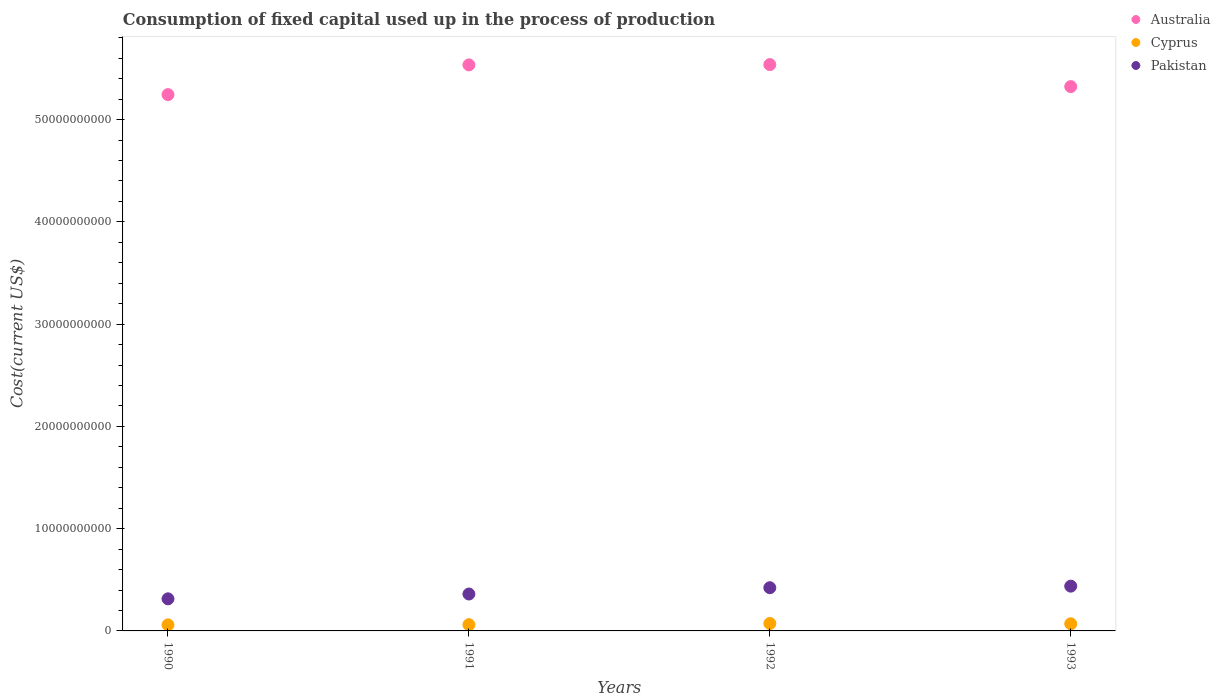What is the amount consumed in the process of production in Cyprus in 1993?
Ensure brevity in your answer.  6.96e+08. Across all years, what is the maximum amount consumed in the process of production in Pakistan?
Provide a short and direct response. 4.38e+09. Across all years, what is the minimum amount consumed in the process of production in Pakistan?
Provide a short and direct response. 3.14e+09. In which year was the amount consumed in the process of production in Pakistan maximum?
Give a very brief answer. 1993. What is the total amount consumed in the process of production in Australia in the graph?
Your answer should be very brief. 2.16e+11. What is the difference between the amount consumed in the process of production in Cyprus in 1991 and that in 1993?
Offer a very short reply. -8.46e+07. What is the difference between the amount consumed in the process of production in Australia in 1993 and the amount consumed in the process of production in Cyprus in 1990?
Your answer should be compact. 5.26e+1. What is the average amount consumed in the process of production in Australia per year?
Offer a very short reply. 5.41e+1. In the year 1992, what is the difference between the amount consumed in the process of production in Australia and amount consumed in the process of production in Cyprus?
Provide a short and direct response. 5.47e+1. In how many years, is the amount consumed in the process of production in Australia greater than 2000000000 US$?
Give a very brief answer. 4. What is the ratio of the amount consumed in the process of production in Australia in 1990 to that in 1992?
Give a very brief answer. 0.95. Is the amount consumed in the process of production in Pakistan in 1991 less than that in 1992?
Provide a succinct answer. Yes. What is the difference between the highest and the second highest amount consumed in the process of production in Cyprus?
Offer a very short reply. 3.25e+07. What is the difference between the highest and the lowest amount consumed in the process of production in Cyprus?
Make the answer very short. 1.37e+08. In how many years, is the amount consumed in the process of production in Cyprus greater than the average amount consumed in the process of production in Cyprus taken over all years?
Ensure brevity in your answer.  2. Does the amount consumed in the process of production in Cyprus monotonically increase over the years?
Your response must be concise. No. Is the amount consumed in the process of production in Cyprus strictly greater than the amount consumed in the process of production in Australia over the years?
Make the answer very short. No. How many years are there in the graph?
Make the answer very short. 4. Does the graph contain any zero values?
Provide a succinct answer. No. Does the graph contain grids?
Make the answer very short. No. How are the legend labels stacked?
Your response must be concise. Vertical. What is the title of the graph?
Provide a succinct answer. Consumption of fixed capital used up in the process of production. Does "Yemen, Rep." appear as one of the legend labels in the graph?
Give a very brief answer. No. What is the label or title of the Y-axis?
Offer a very short reply. Cost(current US$). What is the Cost(current US$) in Australia in 1990?
Ensure brevity in your answer.  5.24e+1. What is the Cost(current US$) in Cyprus in 1990?
Keep it short and to the point. 5.92e+08. What is the Cost(current US$) of Pakistan in 1990?
Offer a very short reply. 3.14e+09. What is the Cost(current US$) in Australia in 1991?
Offer a very short reply. 5.54e+1. What is the Cost(current US$) in Cyprus in 1991?
Ensure brevity in your answer.  6.12e+08. What is the Cost(current US$) of Pakistan in 1991?
Ensure brevity in your answer.  3.61e+09. What is the Cost(current US$) of Australia in 1992?
Offer a very short reply. 5.54e+1. What is the Cost(current US$) in Cyprus in 1992?
Offer a very short reply. 7.29e+08. What is the Cost(current US$) of Pakistan in 1992?
Keep it short and to the point. 4.23e+09. What is the Cost(current US$) of Australia in 1993?
Give a very brief answer. 5.32e+1. What is the Cost(current US$) of Cyprus in 1993?
Provide a succinct answer. 6.96e+08. What is the Cost(current US$) of Pakistan in 1993?
Your answer should be very brief. 4.38e+09. Across all years, what is the maximum Cost(current US$) in Australia?
Offer a terse response. 5.54e+1. Across all years, what is the maximum Cost(current US$) of Cyprus?
Offer a very short reply. 7.29e+08. Across all years, what is the maximum Cost(current US$) in Pakistan?
Make the answer very short. 4.38e+09. Across all years, what is the minimum Cost(current US$) of Australia?
Offer a terse response. 5.24e+1. Across all years, what is the minimum Cost(current US$) in Cyprus?
Provide a short and direct response. 5.92e+08. Across all years, what is the minimum Cost(current US$) of Pakistan?
Keep it short and to the point. 3.14e+09. What is the total Cost(current US$) of Australia in the graph?
Provide a short and direct response. 2.16e+11. What is the total Cost(current US$) in Cyprus in the graph?
Your answer should be very brief. 2.63e+09. What is the total Cost(current US$) of Pakistan in the graph?
Offer a terse response. 1.54e+1. What is the difference between the Cost(current US$) in Australia in 1990 and that in 1991?
Your answer should be very brief. -2.91e+09. What is the difference between the Cost(current US$) in Cyprus in 1990 and that in 1991?
Your response must be concise. -1.96e+07. What is the difference between the Cost(current US$) of Pakistan in 1990 and that in 1991?
Provide a short and direct response. -4.72e+08. What is the difference between the Cost(current US$) of Australia in 1990 and that in 1992?
Offer a very short reply. -2.94e+09. What is the difference between the Cost(current US$) of Cyprus in 1990 and that in 1992?
Offer a very short reply. -1.37e+08. What is the difference between the Cost(current US$) of Pakistan in 1990 and that in 1992?
Your answer should be compact. -1.09e+09. What is the difference between the Cost(current US$) of Australia in 1990 and that in 1993?
Offer a terse response. -7.84e+08. What is the difference between the Cost(current US$) of Cyprus in 1990 and that in 1993?
Provide a short and direct response. -1.04e+08. What is the difference between the Cost(current US$) in Pakistan in 1990 and that in 1993?
Give a very brief answer. -1.24e+09. What is the difference between the Cost(current US$) in Australia in 1991 and that in 1992?
Give a very brief answer. -2.84e+07. What is the difference between the Cost(current US$) in Cyprus in 1991 and that in 1992?
Your answer should be compact. -1.17e+08. What is the difference between the Cost(current US$) in Pakistan in 1991 and that in 1992?
Offer a terse response. -6.16e+08. What is the difference between the Cost(current US$) of Australia in 1991 and that in 1993?
Provide a short and direct response. 2.12e+09. What is the difference between the Cost(current US$) in Cyprus in 1991 and that in 1993?
Your response must be concise. -8.46e+07. What is the difference between the Cost(current US$) in Pakistan in 1991 and that in 1993?
Keep it short and to the point. -7.68e+08. What is the difference between the Cost(current US$) in Australia in 1992 and that in 1993?
Make the answer very short. 2.15e+09. What is the difference between the Cost(current US$) in Cyprus in 1992 and that in 1993?
Offer a terse response. 3.25e+07. What is the difference between the Cost(current US$) in Pakistan in 1992 and that in 1993?
Offer a terse response. -1.52e+08. What is the difference between the Cost(current US$) of Australia in 1990 and the Cost(current US$) of Cyprus in 1991?
Offer a very short reply. 5.18e+1. What is the difference between the Cost(current US$) of Australia in 1990 and the Cost(current US$) of Pakistan in 1991?
Provide a succinct answer. 4.88e+1. What is the difference between the Cost(current US$) of Cyprus in 1990 and the Cost(current US$) of Pakistan in 1991?
Your answer should be very brief. -3.02e+09. What is the difference between the Cost(current US$) in Australia in 1990 and the Cost(current US$) in Cyprus in 1992?
Your response must be concise. 5.17e+1. What is the difference between the Cost(current US$) of Australia in 1990 and the Cost(current US$) of Pakistan in 1992?
Make the answer very short. 4.82e+1. What is the difference between the Cost(current US$) of Cyprus in 1990 and the Cost(current US$) of Pakistan in 1992?
Offer a terse response. -3.63e+09. What is the difference between the Cost(current US$) in Australia in 1990 and the Cost(current US$) in Cyprus in 1993?
Offer a very short reply. 5.17e+1. What is the difference between the Cost(current US$) of Australia in 1990 and the Cost(current US$) of Pakistan in 1993?
Your answer should be very brief. 4.81e+1. What is the difference between the Cost(current US$) in Cyprus in 1990 and the Cost(current US$) in Pakistan in 1993?
Keep it short and to the point. -3.79e+09. What is the difference between the Cost(current US$) of Australia in 1991 and the Cost(current US$) of Cyprus in 1992?
Keep it short and to the point. 5.46e+1. What is the difference between the Cost(current US$) in Australia in 1991 and the Cost(current US$) in Pakistan in 1992?
Your answer should be very brief. 5.11e+1. What is the difference between the Cost(current US$) of Cyprus in 1991 and the Cost(current US$) of Pakistan in 1992?
Offer a very short reply. -3.61e+09. What is the difference between the Cost(current US$) in Australia in 1991 and the Cost(current US$) in Cyprus in 1993?
Give a very brief answer. 5.47e+1. What is the difference between the Cost(current US$) of Australia in 1991 and the Cost(current US$) of Pakistan in 1993?
Offer a terse response. 5.10e+1. What is the difference between the Cost(current US$) of Cyprus in 1991 and the Cost(current US$) of Pakistan in 1993?
Make the answer very short. -3.77e+09. What is the difference between the Cost(current US$) of Australia in 1992 and the Cost(current US$) of Cyprus in 1993?
Offer a terse response. 5.47e+1. What is the difference between the Cost(current US$) in Australia in 1992 and the Cost(current US$) in Pakistan in 1993?
Your answer should be compact. 5.10e+1. What is the difference between the Cost(current US$) in Cyprus in 1992 and the Cost(current US$) in Pakistan in 1993?
Ensure brevity in your answer.  -3.65e+09. What is the average Cost(current US$) in Australia per year?
Make the answer very short. 5.41e+1. What is the average Cost(current US$) of Cyprus per year?
Give a very brief answer. 6.57e+08. What is the average Cost(current US$) in Pakistan per year?
Give a very brief answer. 3.84e+09. In the year 1990, what is the difference between the Cost(current US$) of Australia and Cost(current US$) of Cyprus?
Give a very brief answer. 5.19e+1. In the year 1990, what is the difference between the Cost(current US$) of Australia and Cost(current US$) of Pakistan?
Your answer should be very brief. 4.93e+1. In the year 1990, what is the difference between the Cost(current US$) of Cyprus and Cost(current US$) of Pakistan?
Offer a very short reply. -2.55e+09. In the year 1991, what is the difference between the Cost(current US$) in Australia and Cost(current US$) in Cyprus?
Your answer should be compact. 5.47e+1. In the year 1991, what is the difference between the Cost(current US$) of Australia and Cost(current US$) of Pakistan?
Make the answer very short. 5.17e+1. In the year 1991, what is the difference between the Cost(current US$) in Cyprus and Cost(current US$) in Pakistan?
Provide a short and direct response. -3.00e+09. In the year 1992, what is the difference between the Cost(current US$) of Australia and Cost(current US$) of Cyprus?
Keep it short and to the point. 5.47e+1. In the year 1992, what is the difference between the Cost(current US$) in Australia and Cost(current US$) in Pakistan?
Give a very brief answer. 5.12e+1. In the year 1992, what is the difference between the Cost(current US$) in Cyprus and Cost(current US$) in Pakistan?
Ensure brevity in your answer.  -3.50e+09. In the year 1993, what is the difference between the Cost(current US$) of Australia and Cost(current US$) of Cyprus?
Your response must be concise. 5.25e+1. In the year 1993, what is the difference between the Cost(current US$) of Australia and Cost(current US$) of Pakistan?
Ensure brevity in your answer.  4.89e+1. In the year 1993, what is the difference between the Cost(current US$) of Cyprus and Cost(current US$) of Pakistan?
Provide a short and direct response. -3.68e+09. What is the ratio of the Cost(current US$) in Australia in 1990 to that in 1991?
Your answer should be compact. 0.95. What is the ratio of the Cost(current US$) in Cyprus in 1990 to that in 1991?
Give a very brief answer. 0.97. What is the ratio of the Cost(current US$) of Pakistan in 1990 to that in 1991?
Your answer should be very brief. 0.87. What is the ratio of the Cost(current US$) in Australia in 1990 to that in 1992?
Give a very brief answer. 0.95. What is the ratio of the Cost(current US$) in Cyprus in 1990 to that in 1992?
Your answer should be compact. 0.81. What is the ratio of the Cost(current US$) of Pakistan in 1990 to that in 1992?
Provide a short and direct response. 0.74. What is the ratio of the Cost(current US$) of Australia in 1990 to that in 1993?
Your answer should be compact. 0.99. What is the ratio of the Cost(current US$) of Cyprus in 1990 to that in 1993?
Provide a short and direct response. 0.85. What is the ratio of the Cost(current US$) of Pakistan in 1990 to that in 1993?
Make the answer very short. 0.72. What is the ratio of the Cost(current US$) in Cyprus in 1991 to that in 1992?
Your answer should be compact. 0.84. What is the ratio of the Cost(current US$) in Pakistan in 1991 to that in 1992?
Provide a succinct answer. 0.85. What is the ratio of the Cost(current US$) of Australia in 1991 to that in 1993?
Keep it short and to the point. 1.04. What is the ratio of the Cost(current US$) in Cyprus in 1991 to that in 1993?
Your answer should be compact. 0.88. What is the ratio of the Cost(current US$) of Pakistan in 1991 to that in 1993?
Make the answer very short. 0.82. What is the ratio of the Cost(current US$) of Australia in 1992 to that in 1993?
Give a very brief answer. 1.04. What is the ratio of the Cost(current US$) of Cyprus in 1992 to that in 1993?
Make the answer very short. 1.05. What is the ratio of the Cost(current US$) of Pakistan in 1992 to that in 1993?
Offer a very short reply. 0.97. What is the difference between the highest and the second highest Cost(current US$) in Australia?
Provide a succinct answer. 2.84e+07. What is the difference between the highest and the second highest Cost(current US$) in Cyprus?
Your answer should be very brief. 3.25e+07. What is the difference between the highest and the second highest Cost(current US$) of Pakistan?
Offer a terse response. 1.52e+08. What is the difference between the highest and the lowest Cost(current US$) of Australia?
Provide a succinct answer. 2.94e+09. What is the difference between the highest and the lowest Cost(current US$) in Cyprus?
Your answer should be compact. 1.37e+08. What is the difference between the highest and the lowest Cost(current US$) in Pakistan?
Make the answer very short. 1.24e+09. 